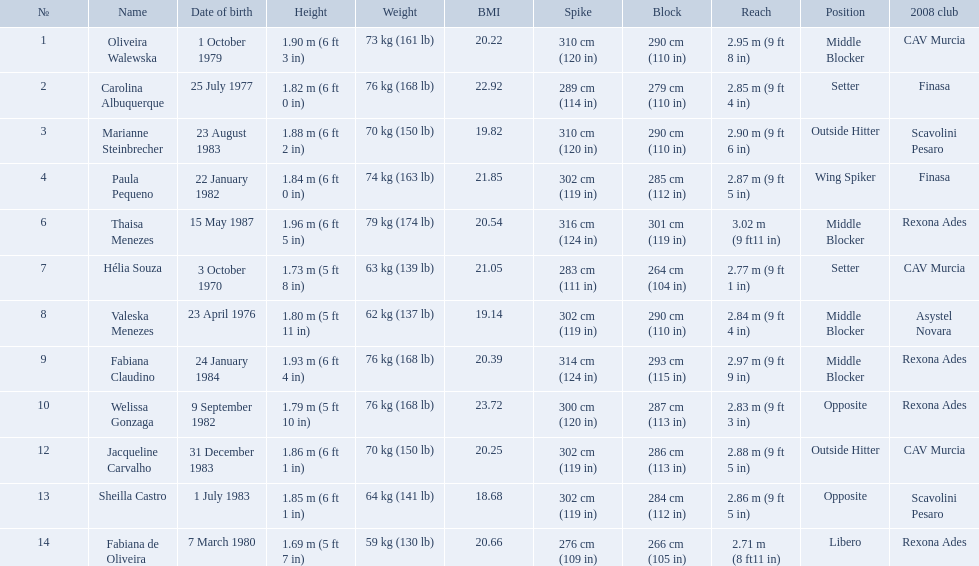What are all of the names? Oliveira Walewska, Carolina Albuquerque, Marianne Steinbrecher, Paula Pequeno, Thaisa Menezes, Hélia Souza, Valeska Menezes, Fabiana Claudino, Welissa Gonzaga, Jacqueline Carvalho, Sheilla Castro, Fabiana de Oliveira. What are their weights? 73 kg (161 lb), 76 kg (168 lb), 70 kg (150 lb), 74 kg (163 lb), 79 kg (174 lb), 63 kg (139 lb), 62 kg (137 lb), 76 kg (168 lb), 76 kg (168 lb), 70 kg (150 lb), 64 kg (141 lb), 59 kg (130 lb). How much did helia souza, fabiana de oliveira, and sheilla castro weigh? Hélia Souza, Sheilla Castro, Fabiana de Oliveira. Would you be able to parse every entry in this table? {'header': ['№', 'Name', 'Date of birth', 'Height', 'Weight', 'BMI', 'Spike', 'Block', 'Reach', 'Position', '2008 club'], 'rows': [['1', 'Oliveira Walewska', '1 October 1979', '1.90\xa0m (6\xa0ft 3\xa0in)', '73\xa0kg (161\xa0lb)', '20.22', '310\xa0cm (120\xa0in)', '290\xa0cm (110\xa0in)', '2.95\xa0m (9\xa0ft 8\xa0in)', 'Middle Blocker', 'CAV Murcia'], ['2', 'Carolina Albuquerque', '25 July 1977', '1.82\xa0m (6\xa0ft 0\xa0in)', '76\xa0kg (168\xa0lb)', '22.92', '289\xa0cm (114\xa0in)', '279\xa0cm (110\xa0in)', '2.85\xa0m (9\xa0ft 4\xa0in)', 'Setter', 'Finasa'], ['3', 'Marianne Steinbrecher', '23 August 1983', '1.88\xa0m (6\xa0ft 2\xa0in)', '70\xa0kg (150\xa0lb)', '19.82', '310\xa0cm (120\xa0in)', '290\xa0cm (110\xa0in)', '2.90\xa0m (9\xa0ft 6\xa0in)', 'Outside Hitter', 'Scavolini Pesaro'], ['4', 'Paula Pequeno', '22 January 1982', '1.84\xa0m (6\xa0ft 0\xa0in)', '74\xa0kg (163\xa0lb)', '21.85', '302\xa0cm (119\xa0in)', '285\xa0cm (112\xa0in)', '2.87\xa0m (9\xa0ft 5\xa0in)', 'Wing Spiker', 'Finasa'], ['6', 'Thaisa Menezes', '15 May 1987', '1.96\xa0m (6\xa0ft 5\xa0in)', '79\xa0kg (174\xa0lb)', '20.54', '316\xa0cm (124\xa0in)', '301\xa0cm (119\xa0in)', '3.02\xa0m (9\xa0ft11\xa0in)', 'Middle Blocker', 'Rexona Ades'], ['7', 'Hélia Souza', '3 October 1970', '1.73\xa0m (5\xa0ft 8\xa0in)', '63\xa0kg (139\xa0lb)', '21.05', '283\xa0cm (111\xa0in)', '264\xa0cm (104\xa0in)', '2.77\xa0m (9\xa0ft 1\xa0in)', 'Setter', 'CAV Murcia'], ['8', 'Valeska Menezes', '23 April 1976', '1.80\xa0m (5\xa0ft 11\xa0in)', '62\xa0kg (137\xa0lb)', '19.14', '302\xa0cm (119\xa0in)', '290\xa0cm (110\xa0in)', '2.84\xa0m (9\xa0ft 4\xa0in)', 'Middle Blocker', 'Asystel Novara'], ['9', 'Fabiana Claudino', '24 January 1984', '1.93\xa0m (6\xa0ft 4\xa0in)', '76\xa0kg (168\xa0lb)', '20.39', '314\xa0cm (124\xa0in)', '293\xa0cm (115\xa0in)', '2.97\xa0m (9\xa0ft 9\xa0in)', 'Middle Blocker', 'Rexona Ades'], ['10', 'Welissa Gonzaga', '9 September 1982', '1.79\xa0m (5\xa0ft 10\xa0in)', '76\xa0kg (168\xa0lb)', '23.72', '300\xa0cm (120\xa0in)', '287\xa0cm (113\xa0in)', '2.83\xa0m (9\xa0ft 3\xa0in)', 'Opposite', 'Rexona Ades'], ['12', 'Jacqueline Carvalho', '31 December 1983', '1.86\xa0m (6\xa0ft 1\xa0in)', '70\xa0kg (150\xa0lb)', '20.25', '302\xa0cm (119\xa0in)', '286\xa0cm (113\xa0in)', '2.88\xa0m (9\xa0ft 5\xa0in)', 'Outside Hitter', 'CAV Murcia'], ['13', 'Sheilla Castro', '1 July 1983', '1.85\xa0m (6\xa0ft 1\xa0in)', '64\xa0kg (141\xa0lb)', '18.68', '302\xa0cm (119\xa0in)', '284\xa0cm (112\xa0in)', '2.86\xa0m (9\xa0ft 5\xa0in)', 'Opposite', 'Scavolini Pesaro'], ['14', 'Fabiana de Oliveira', '7 March 1980', '1.69\xa0m (5\xa0ft 7\xa0in)', '59\xa0kg (130\xa0lb)', '20.66', '276\xa0cm (109\xa0in)', '266\xa0cm (105\xa0in)', '2.71\xa0m (8\xa0ft11\xa0in)', 'Libero', 'Rexona Ades']]} And who weighed more? Sheilla Castro. How much does fabiana de oliveira weigh? 76 kg (168 lb). How much does helia souza weigh? 63 kg (139 lb). How much does sheilla castro weigh? 64 kg (141 lb). Whose weight did the original question asker incorrectly believe to be the heaviest (they are the second heaviest)? Sheilla Castro. Who played during the brazil at the 2008 summer olympics event? Oliveira Walewska, Carolina Albuquerque, Marianne Steinbrecher, Paula Pequeno, Thaisa Menezes, Hélia Souza, Valeska Menezes, Fabiana Claudino, Welissa Gonzaga, Jacqueline Carvalho, Sheilla Castro, Fabiana de Oliveira. And what was the recorded height of each player? 1.90 m (6 ft 3 in), 1.82 m (6 ft 0 in), 1.88 m (6 ft 2 in), 1.84 m (6 ft 0 in), 1.96 m (6 ft 5 in), 1.73 m (5 ft 8 in), 1.80 m (5 ft 11 in), 1.93 m (6 ft 4 in), 1.79 m (5 ft 10 in), 1.86 m (6 ft 1 in), 1.85 m (6 ft 1 in), 1.69 m (5 ft 7 in). Of those, which player is the shortest? Fabiana de Oliveira. What are the heights of the players? 1.90 m (6 ft 3 in), 1.82 m (6 ft 0 in), 1.88 m (6 ft 2 in), 1.84 m (6 ft 0 in), 1.96 m (6 ft 5 in), 1.73 m (5 ft 8 in), 1.80 m (5 ft 11 in), 1.93 m (6 ft 4 in), 1.79 m (5 ft 10 in), 1.86 m (6 ft 1 in), 1.85 m (6 ft 1 in), 1.69 m (5 ft 7 in). Which of these heights is the shortest? 1.69 m (5 ft 7 in). Which player is 5'7 tall? Fabiana de Oliveira. 